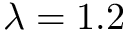<formula> <loc_0><loc_0><loc_500><loc_500>\lambda = 1 . 2</formula> 